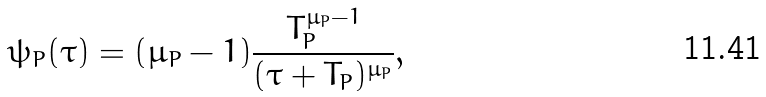Convert formula to latex. <formula><loc_0><loc_0><loc_500><loc_500>\psi _ { P } ( \tau ) = ( \mu _ { P } - 1 ) \frac { T _ { P } ^ { \mu _ { P } - 1 } } { ( \tau + T _ { P } ) ^ { \mu _ { P } } } ,</formula> 